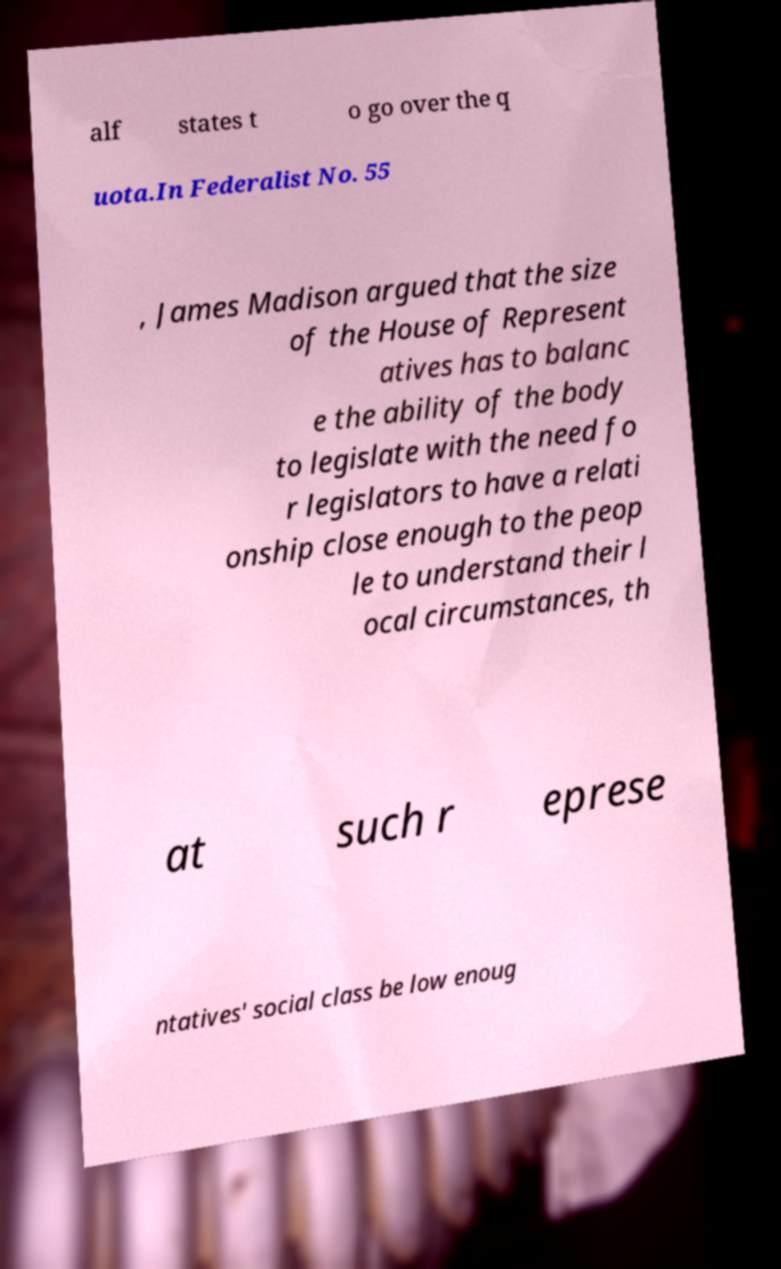Please read and relay the text visible in this image. What does it say? alf states t o go over the q uota.In Federalist No. 55 , James Madison argued that the size of the House of Represent atives has to balanc e the ability of the body to legislate with the need fo r legislators to have a relati onship close enough to the peop le to understand their l ocal circumstances, th at such r eprese ntatives' social class be low enoug 